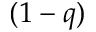Convert formula to latex. <formula><loc_0><loc_0><loc_500><loc_500>( 1 - q )</formula> 